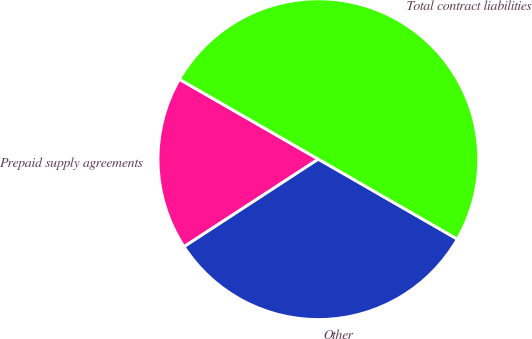<chart> <loc_0><loc_0><loc_500><loc_500><pie_chart><fcel>Prepaid supply agreements<fcel>Other<fcel>Total contract liabilities<nl><fcel>17.5%<fcel>32.5%<fcel>50.0%<nl></chart> 